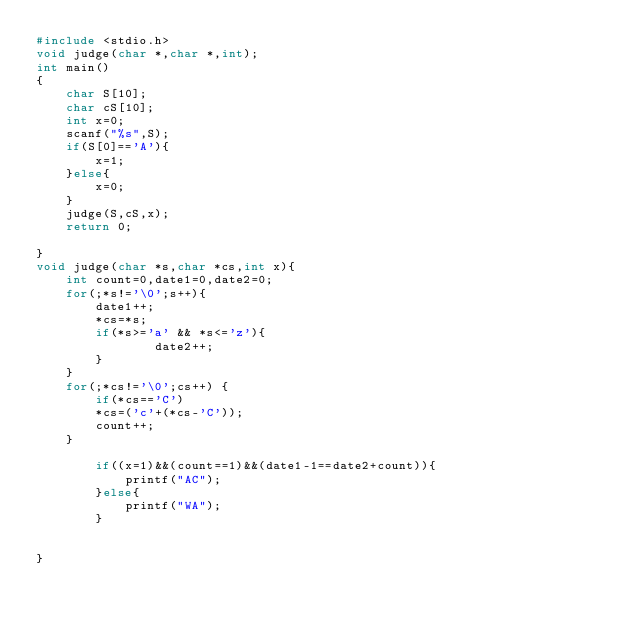<code> <loc_0><loc_0><loc_500><loc_500><_C_>#include <stdio.h>
void judge(char *,char *,int);
int main()
{
    char S[10];
    char cS[10];
    int x=0;
    scanf("%s",S);
    if(S[0]=='A'){
        x=1;
    }else{
        x=0;
    }
    judge(S,cS,x);
    return 0;
    
}
void judge(char *s,char *cs,int x){
    int count=0,date1=0,date2=0;
    for(;*s!='\0';s++){
        date1++;
        *cs=*s;
        if(*s>='a' && *s<='z'){
                date2++;
        }
    }
    for(;*cs!='\0';cs++) {
        if(*cs=='C')
        *cs=('c'+(*cs-'C'));
        count++;
    }
    
        if((x=1)&&(count==1)&&(date1-1==date2+count)){
            printf("AC");
        }else{
            printf("WA");
        }

    
}</code> 